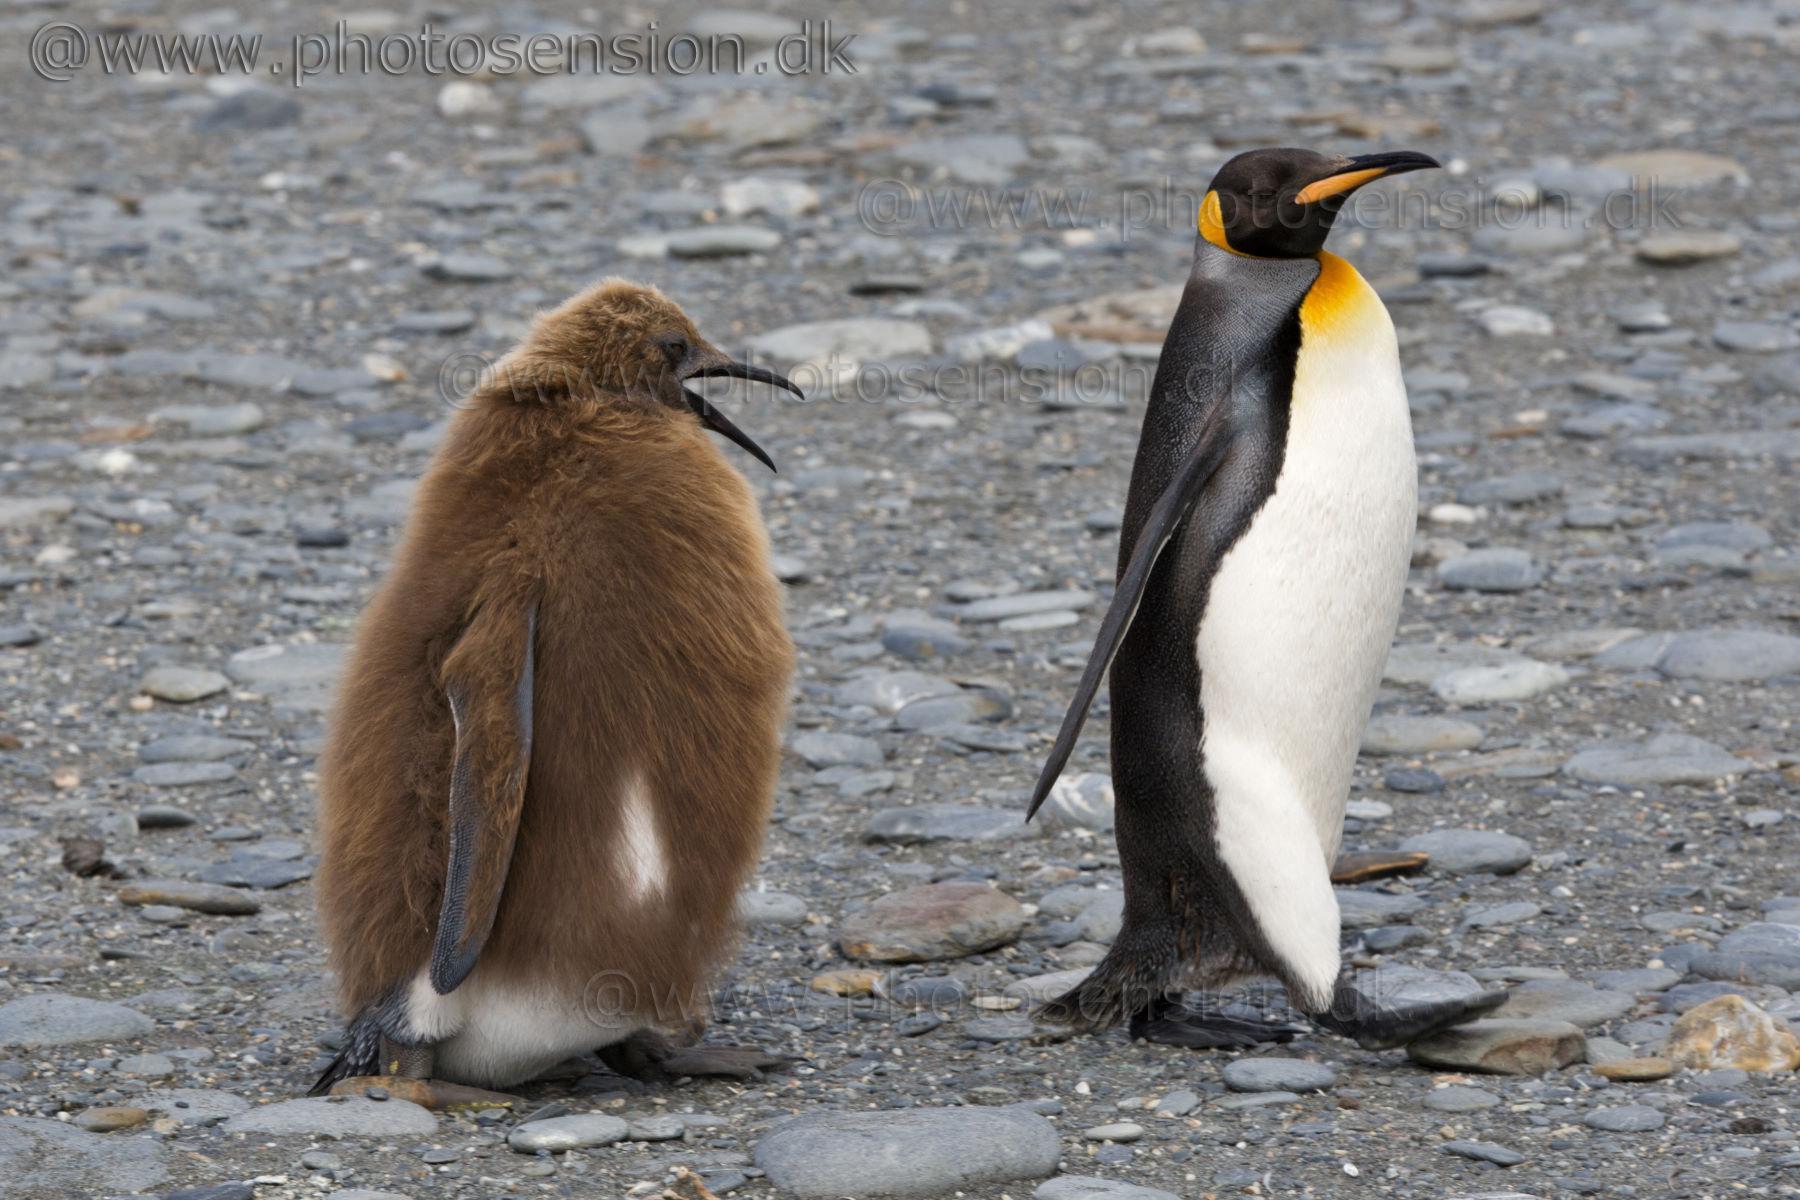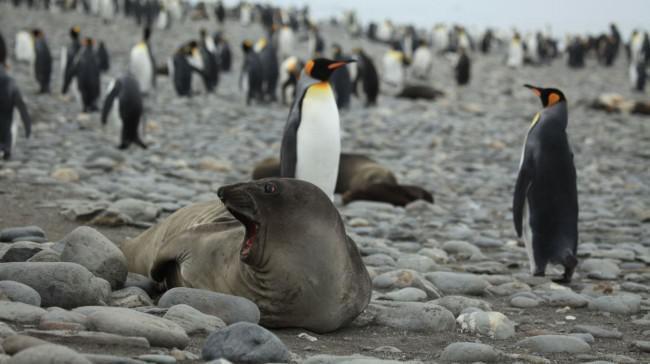The first image is the image on the left, the second image is the image on the right. Given the left and right images, does the statement "One of the images shows a penguin that is brown and fuzzy standing near a black and white penguin." hold true? Answer yes or no. Yes. The first image is the image on the left, the second image is the image on the right. Examine the images to the left and right. Is the description "A seal photobombs in the lower right corner of one of the pictures." accurate? Answer yes or no. No. 